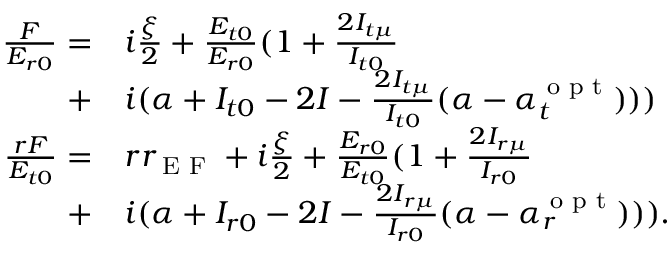<formula> <loc_0><loc_0><loc_500><loc_500>\begin{array} { r l } { \frac { F } { E _ { r 0 } } = } & i \frac { \xi } { 2 } + \frac { E _ { t 0 } } { E _ { r 0 } } ( 1 + \frac { 2 I _ { t \mu } } { I _ { t 0 } } } \\ { + } & i ( \alpha + I _ { t 0 } - 2 I - \frac { 2 I _ { t \mu } } { I _ { t 0 } } ( \alpha - \alpha _ { t } ^ { o p t } ) ) ) } \\ { \frac { r F } { E _ { t 0 } } = } & r r _ { E F } + i \frac { \xi } { 2 } + \frac { E _ { r 0 } } { E _ { t 0 } } ( 1 + \frac { 2 I _ { r \mu } } { I _ { r 0 } } } \\ { + } & i ( \alpha + I _ { r 0 } - 2 I - \frac { 2 I _ { r \mu } } { I _ { r 0 } } ( \alpha - \alpha _ { r } ^ { o p t } ) ) ) . } \end{array}</formula> 